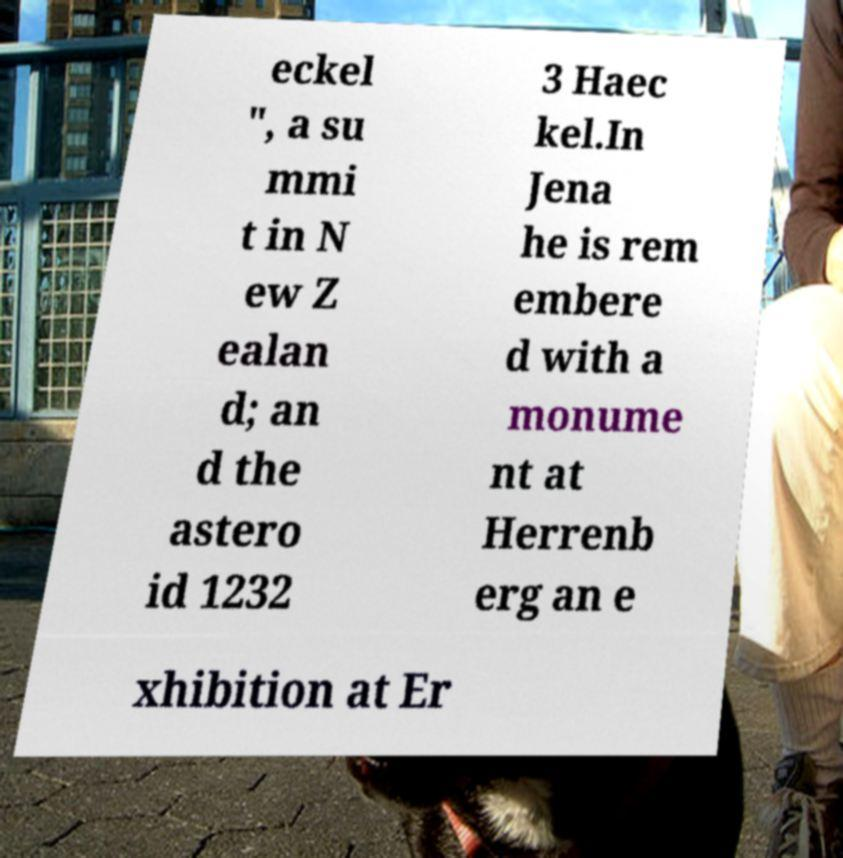Could you extract and type out the text from this image? eckel ", a su mmi t in N ew Z ealan d; an d the astero id 1232 3 Haec kel.In Jena he is rem embere d with a monume nt at Herrenb erg an e xhibition at Er 